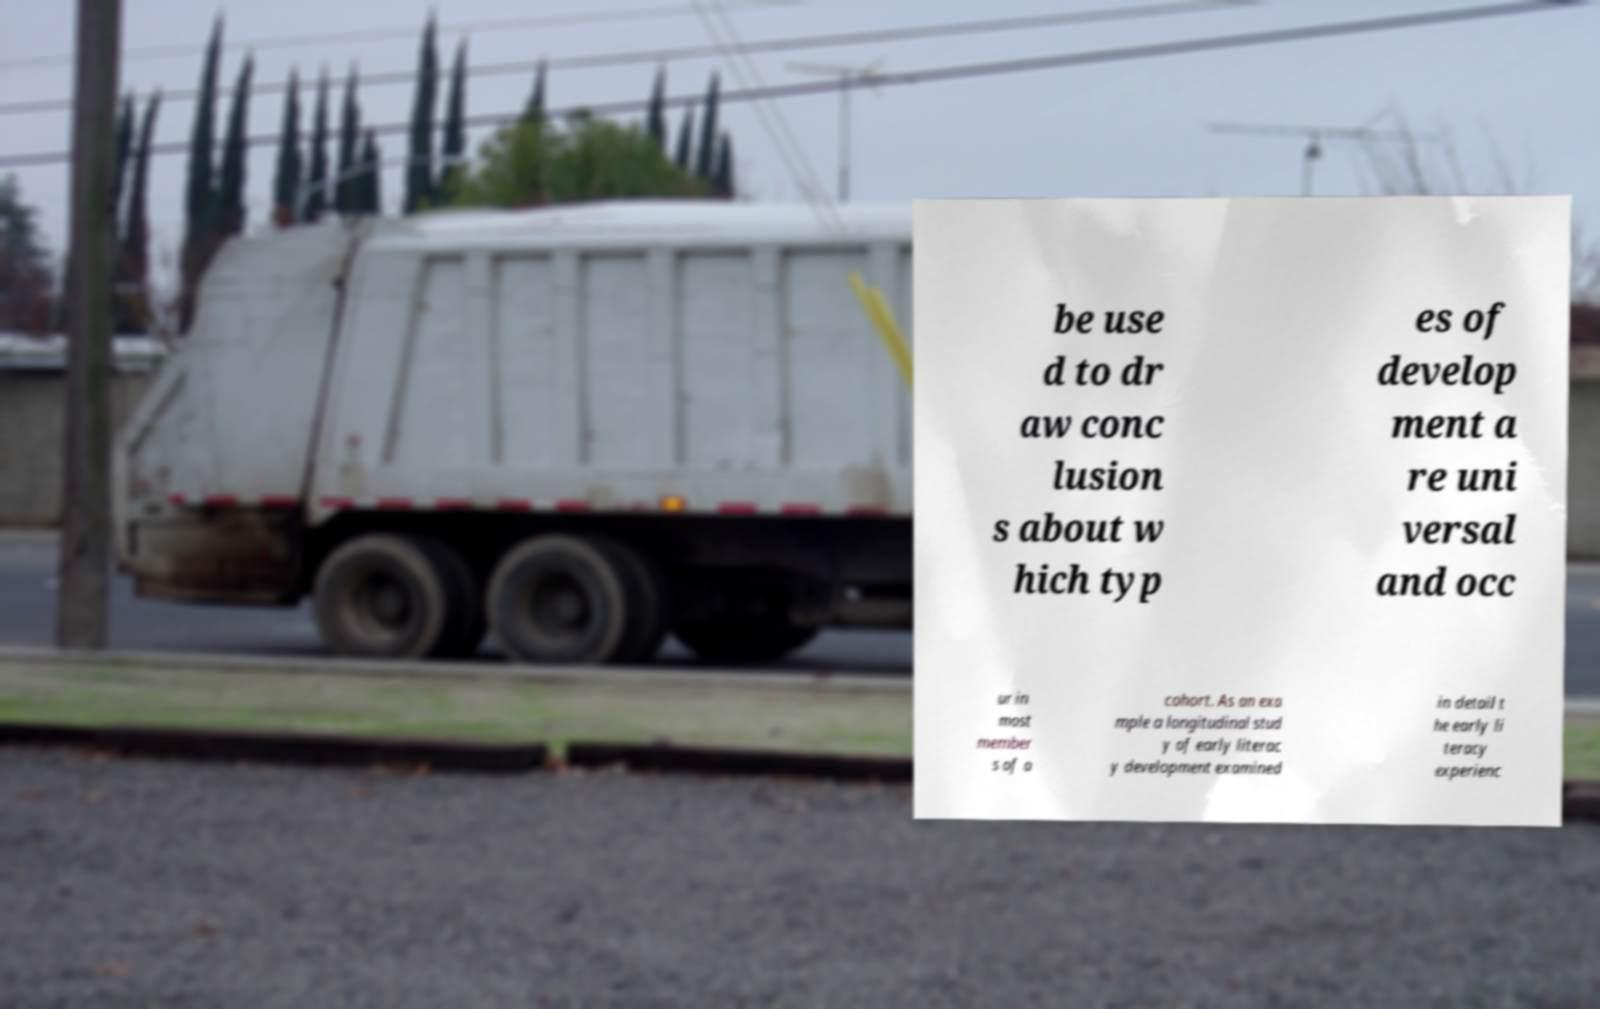What messages or text are displayed in this image? I need them in a readable, typed format. be use d to dr aw conc lusion s about w hich typ es of develop ment a re uni versal and occ ur in most member s of a cohort. As an exa mple a longitudinal stud y of early literac y development examined in detail t he early li teracy experienc 